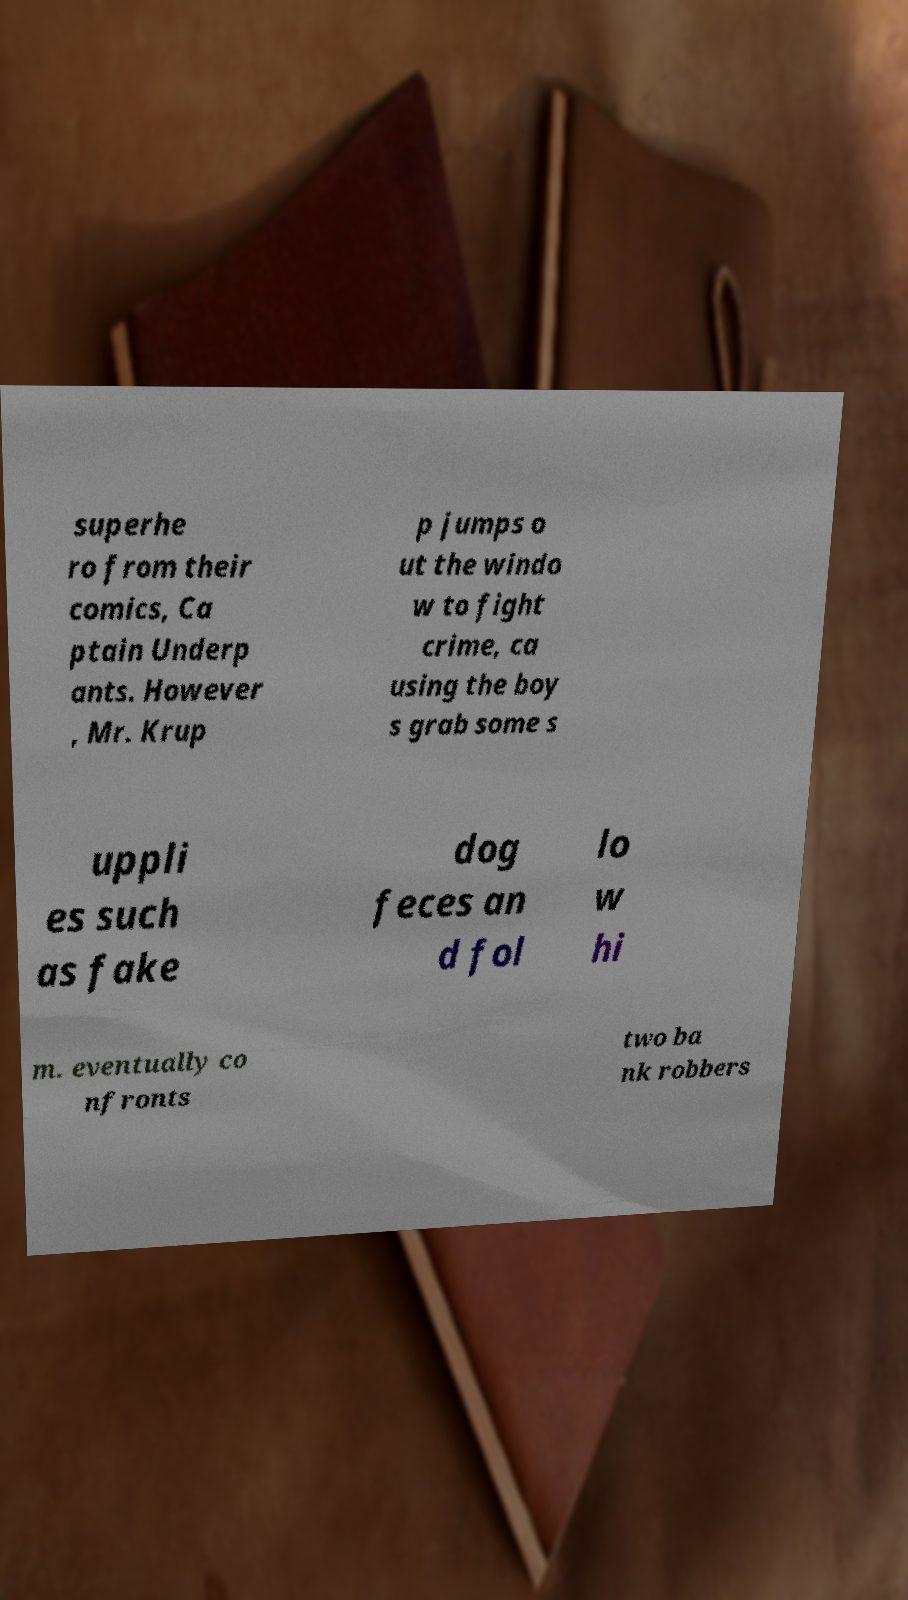There's text embedded in this image that I need extracted. Can you transcribe it verbatim? superhe ro from their comics, Ca ptain Underp ants. However , Mr. Krup p jumps o ut the windo w to fight crime, ca using the boy s grab some s uppli es such as fake dog feces an d fol lo w hi m. eventually co nfronts two ba nk robbers 